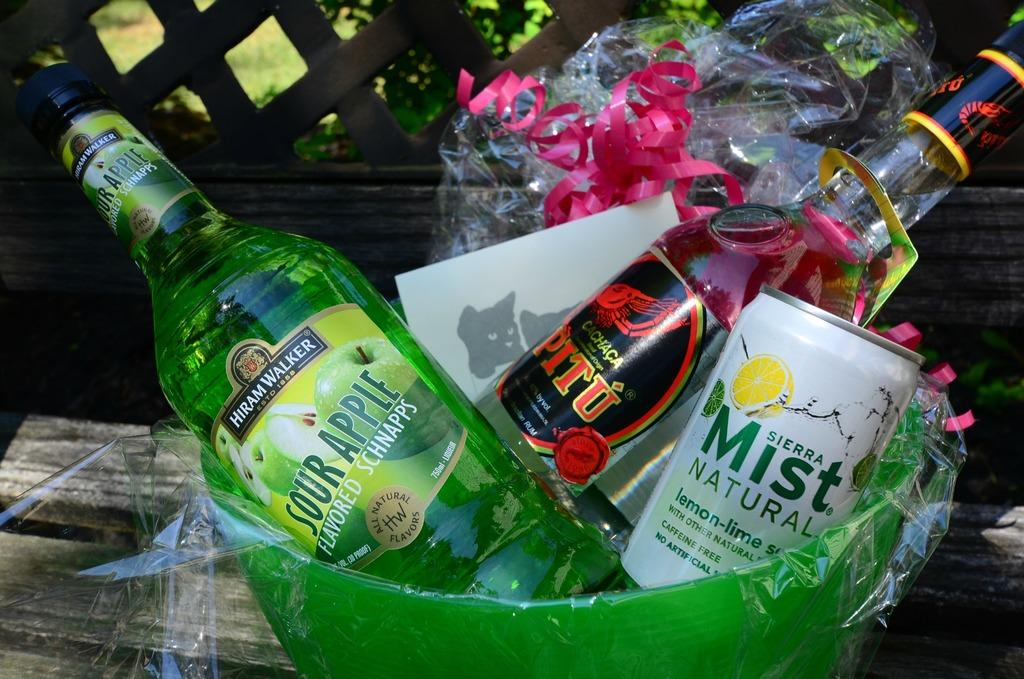What items are in the basket in the image? There are bottles and a tin in the basket. What is covering something in the image? There is a cover in the image. What decorative element is present in the image? There is a ribbon in the image. What type of furniture is in the image? There is a table in the image. What type of natural environment is visible in the background of the image? The background of the image includes plants and grass. Can you tell me how much fuel is being used by the maid in the image? There is no maid or fuel present in the image. What type of receipt is visible in the image? There is no receipt present in the image. 